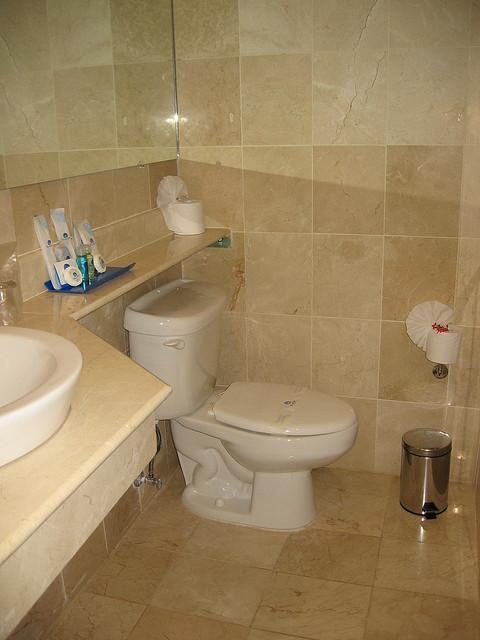Where is this bathroom located?
Pick the correct solution from the four options below to address the question.
Options: Hotel, home, hospital, park. Hotel. 